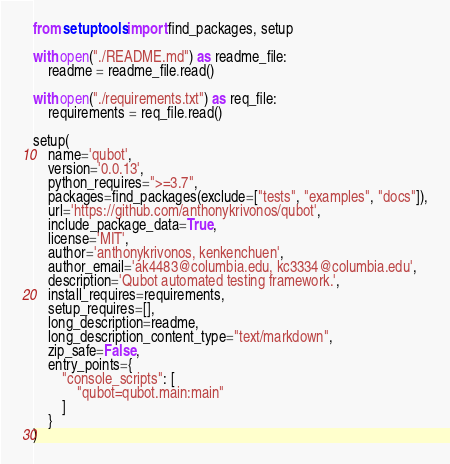Convert code to text. <code><loc_0><loc_0><loc_500><loc_500><_Python_>from setuptools import find_packages, setup

with open("./README.md") as readme_file:
    readme = readme_file.read()

with open("./requirements.txt") as req_file:
    requirements = req_file.read()

setup(
    name='qubot',
    version='0.0.13',
    python_requires=">=3.7",
    packages=find_packages(exclude=["tests", "examples", "docs"]),
    url='https://github.com/anthonykrivonos/qubot',
    include_package_data=True,
    license='MIT',
    author='anthonykrivonos, kenkenchuen',
    author_email='ak4483@columbia.edu, kc3334@columbia.edu',
    description='Qubot automated testing framework.',
    install_requires=requirements,
    setup_requires=[],
    long_description=readme,
    long_description_content_type="text/markdown",
    zip_safe=False,
    entry_points={
        "console_scripts": [
            "qubot=qubot.main:main"
        ]
    }
)
</code> 